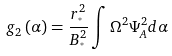<formula> <loc_0><loc_0><loc_500><loc_500>g _ { 2 } \left ( \alpha \right ) = \frac { r _ { ^ { * } } ^ { 2 } } { B _ { ^ { * } } ^ { 2 } } \int \Omega ^ { 2 } \Psi _ { A } ^ { 2 } d \alpha</formula> 